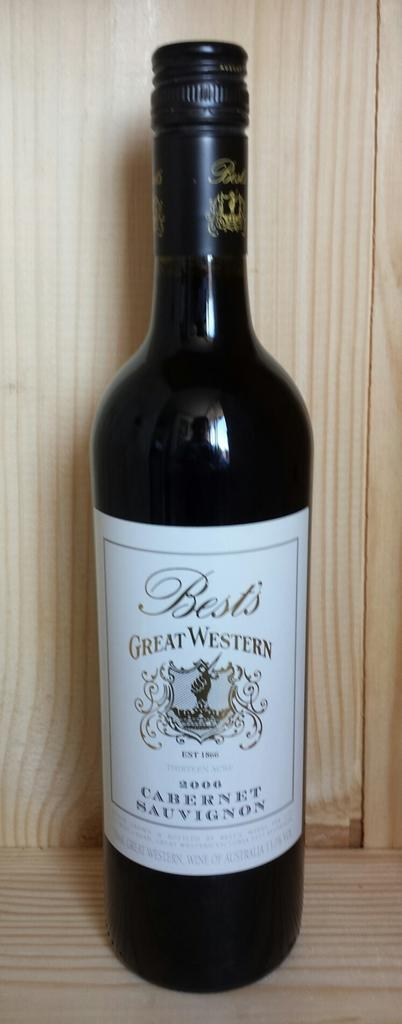<image>
Create a compact narrative representing the image presented. A bottle of Great Western wine with a wooden backdrop 